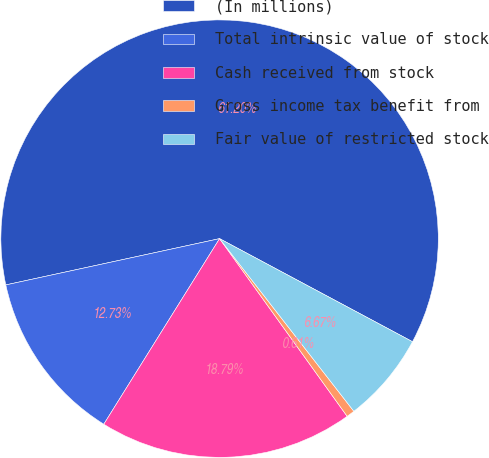Convert chart to OTSL. <chart><loc_0><loc_0><loc_500><loc_500><pie_chart><fcel>(In millions)<fcel>Total intrinsic value of stock<fcel>Cash received from stock<fcel>Gross income tax benefit from<fcel>Fair value of restricted stock<nl><fcel>61.21%<fcel>12.73%<fcel>18.79%<fcel>0.61%<fcel>6.67%<nl></chart> 